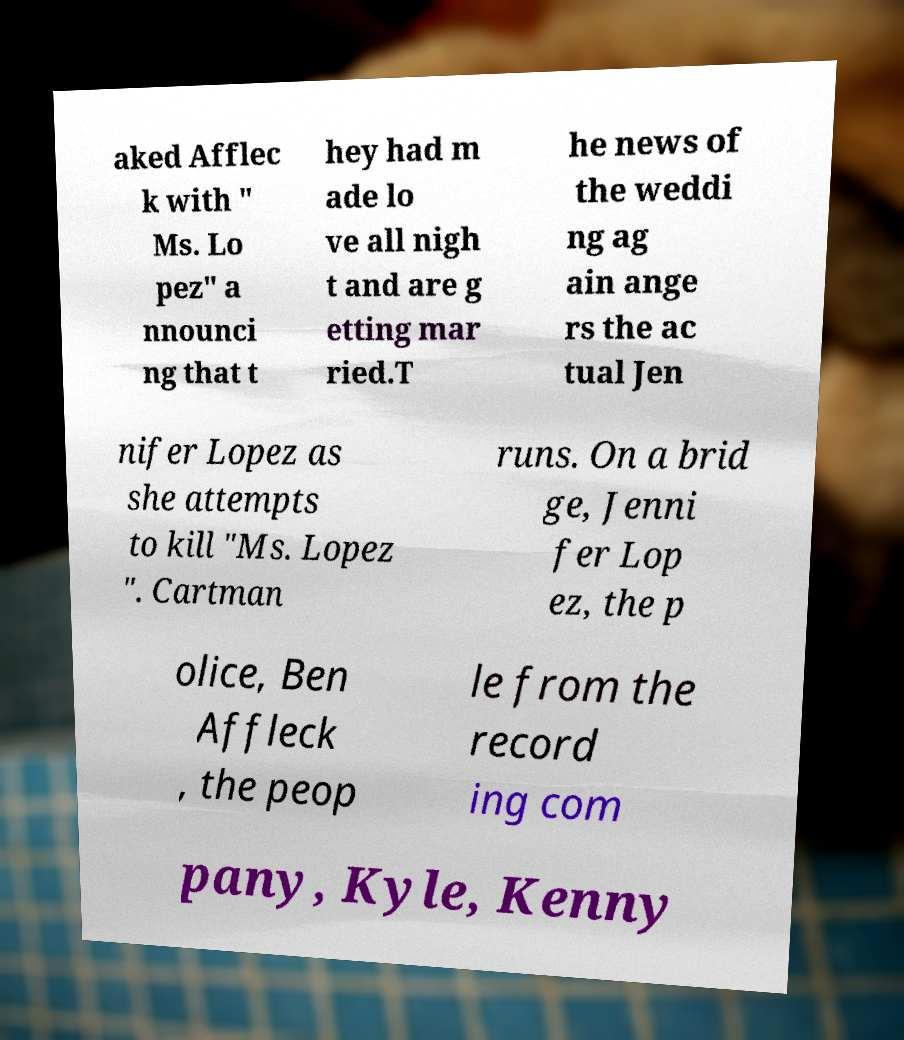Could you assist in decoding the text presented in this image and type it out clearly? aked Afflec k with " Ms. Lo pez" a nnounci ng that t hey had m ade lo ve all nigh t and are g etting mar ried.T he news of the weddi ng ag ain ange rs the ac tual Jen nifer Lopez as she attempts to kill "Ms. Lopez ". Cartman runs. On a brid ge, Jenni fer Lop ez, the p olice, Ben Affleck , the peop le from the record ing com pany, Kyle, Kenny 